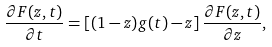Convert formula to latex. <formula><loc_0><loc_0><loc_500><loc_500>\frac { \partial F ( z , t ) } { \partial t } = \left [ ( 1 - z ) g ( t ) - z \right ] \frac { \partial F ( z , t ) } { \partial z } ,</formula> 